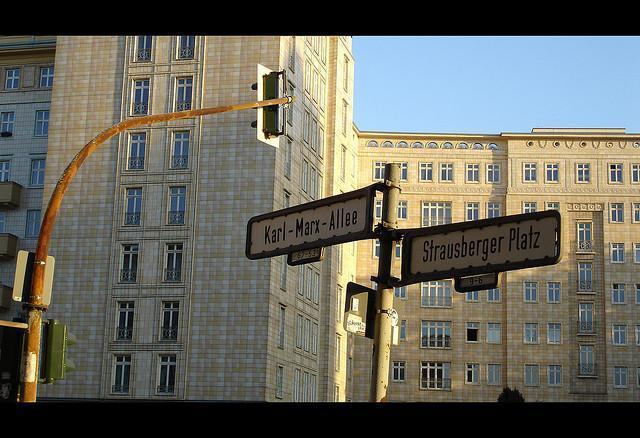How many floors does the building have?
Give a very brief answer. 7. 